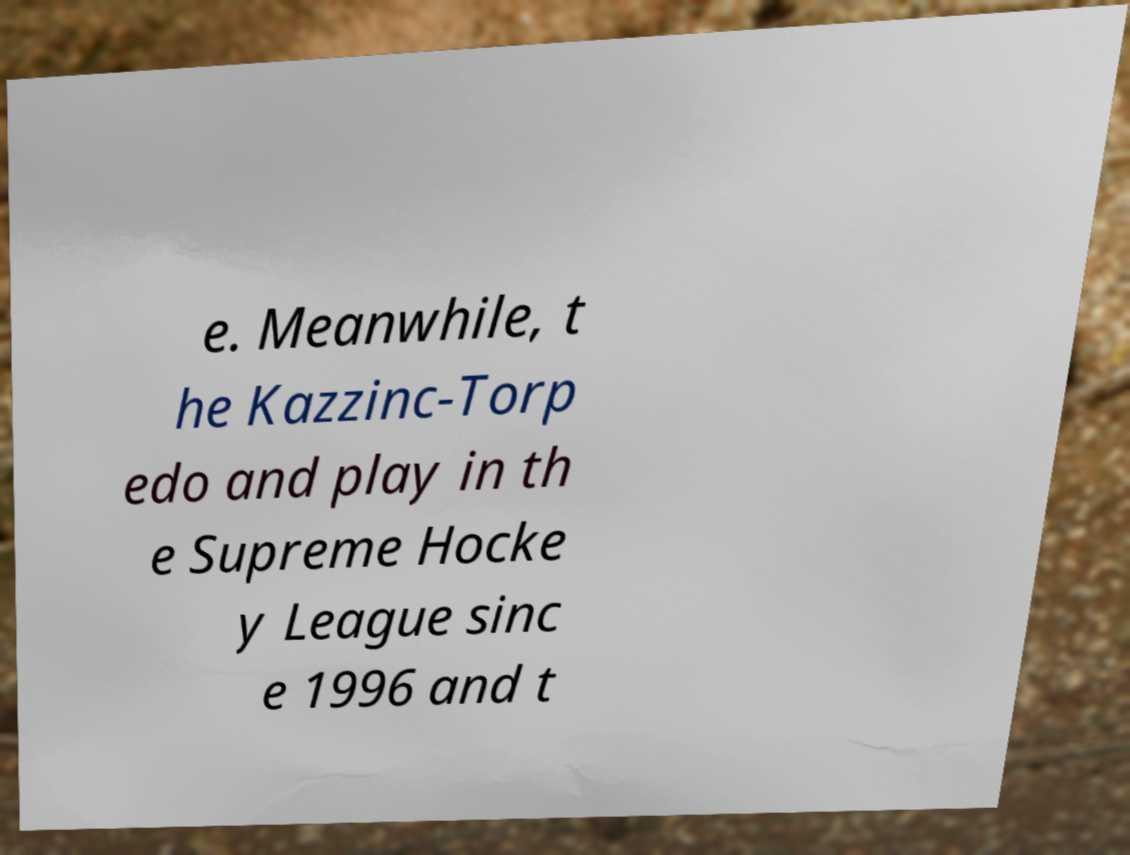Could you assist in decoding the text presented in this image and type it out clearly? e. Meanwhile, t he Kazzinc-Torp edo and play in th e Supreme Hocke y League sinc e 1996 and t 